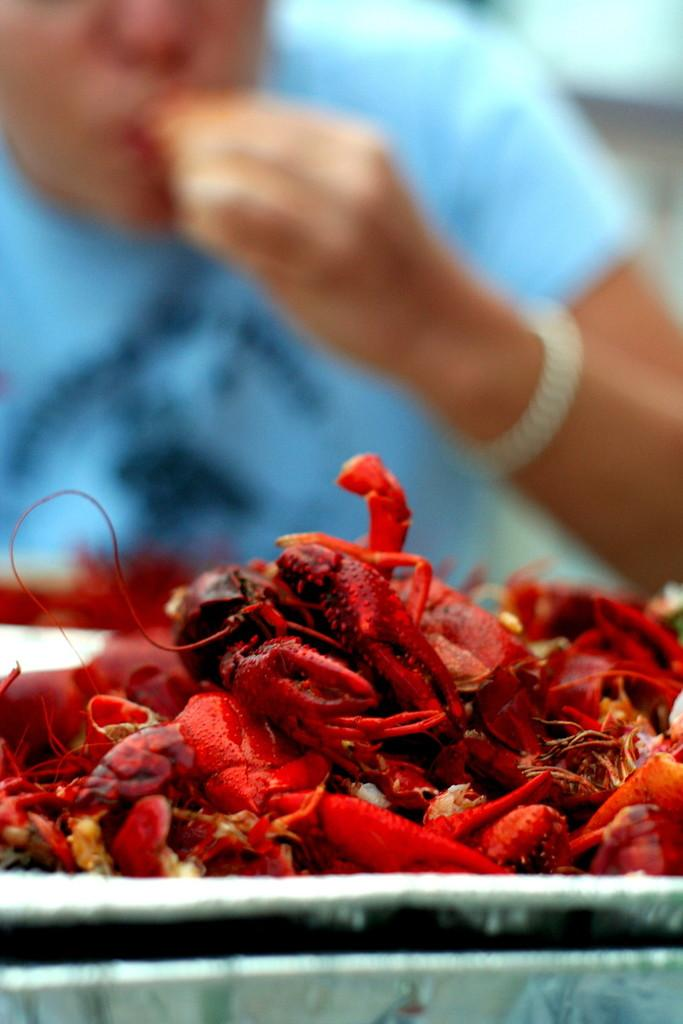What is placed on the table in the image? There are crabs placed on the table in the image. Can you describe the person in the background of the image? Unfortunately, the provided facts do not give any information about the person in the background, so we cannot describe them. What type of coach can be seen in the image? There is no coach present in the image. Is there a baseball game happening in the image? There is no indication of a baseball game or any sports activity in the image. 